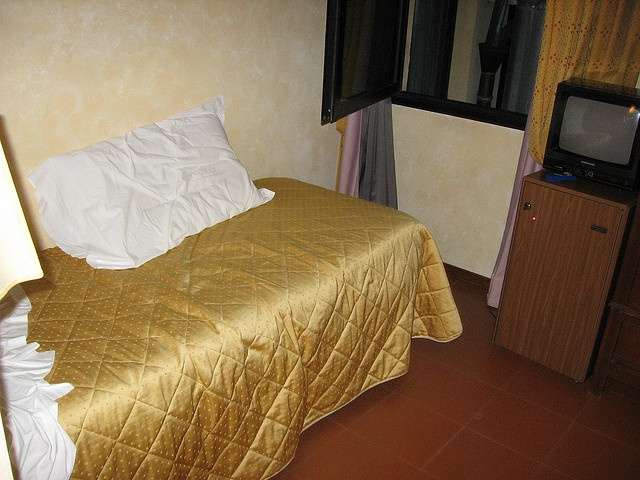Describe the objects in this image and their specific colors. I can see bed in tan, olive, and lightgray tones, tv in tan, black, and gray tones, and remote in tan, navy, black, teal, and gray tones in this image. 